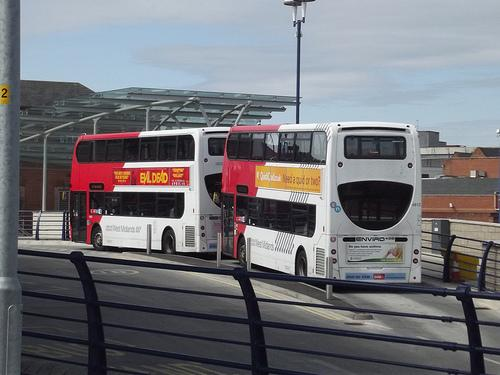Identify any key details about the background in the image. In the background, there is a gray receptacle, a red brick building, and white clouds in the blue sky. Express the function of two prominent features in the photo. The black iron fence railing serves as a barrier, and the double-decker buses provide public transportation. Mention any prominent objects found on the street in the image. There is a white circle on the street and a yellow bin by the railing. Describe the predominant colors in the image, including those of the sky, buses, and other objects. Predominant colors in the image are blue, white, red, yellow, orange, black, and gray. Point out any unique features of the buses. The buses are double-decker with advertisements and gold lettering on the sides. Describe the general setting of the image. The image shows two double-decker buses on a gray roadway with a black metal railing, a yellow bin, a number 2 on a pole, and white clouds in the blue sky. Mention the color and material of the railing in the image. The railing is black and made of metal. Discuss any unique architectural aspects depicted in the image. The image features a red brick building and an intricate black iron fence railing. What are the colors of the two buses in the image? The two buses are red, white, and orange. Describe any specific elements of the buses, such as colors or features. The buses have red and white fronts, white backs, black windows, brake lights, and advertisements on the sides. 